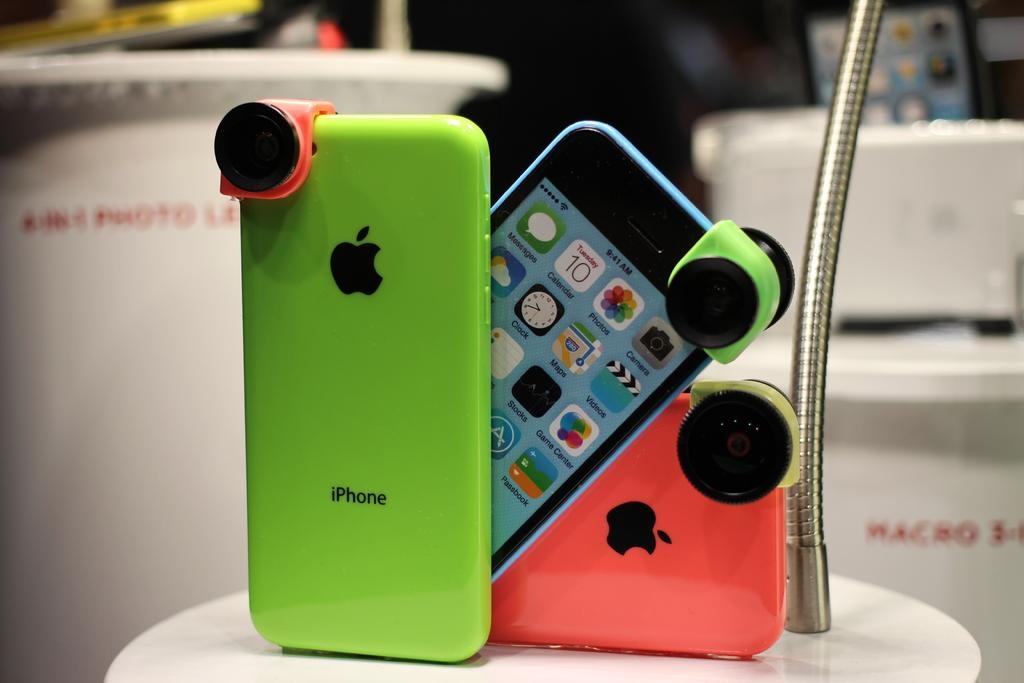<image>
Present a compact description of the photo's key features. A green iPhone is next to a blue and red one. 